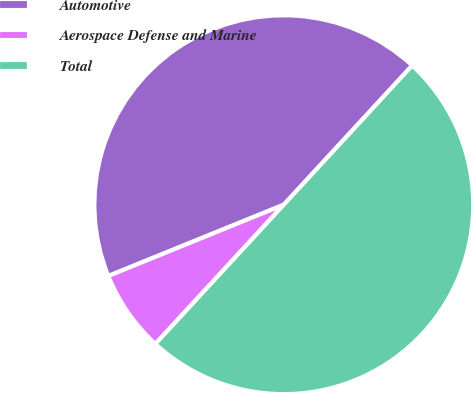<chart> <loc_0><loc_0><loc_500><loc_500><pie_chart><fcel>Automotive<fcel>Aerospace Defense and Marine<fcel>Total<nl><fcel>43.0%<fcel>7.0%<fcel>50.0%<nl></chart> 